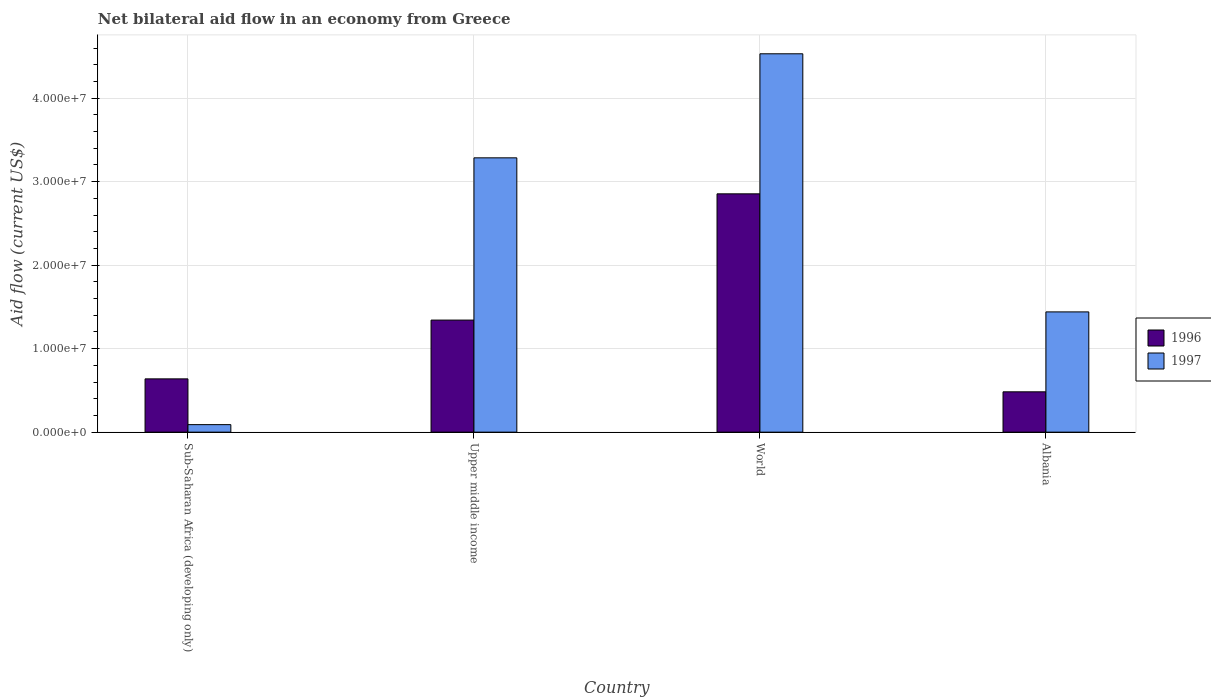How many groups of bars are there?
Your response must be concise. 4. Are the number of bars per tick equal to the number of legend labels?
Ensure brevity in your answer.  Yes. Are the number of bars on each tick of the X-axis equal?
Ensure brevity in your answer.  Yes. What is the label of the 2nd group of bars from the left?
Keep it short and to the point. Upper middle income. What is the net bilateral aid flow in 1997 in Albania?
Offer a very short reply. 1.44e+07. Across all countries, what is the maximum net bilateral aid flow in 1996?
Provide a short and direct response. 2.85e+07. In which country was the net bilateral aid flow in 1997 minimum?
Your answer should be very brief. Sub-Saharan Africa (developing only). What is the total net bilateral aid flow in 1996 in the graph?
Offer a terse response. 5.32e+07. What is the difference between the net bilateral aid flow in 1997 in Albania and that in World?
Provide a short and direct response. -3.09e+07. What is the difference between the net bilateral aid flow in 1997 in Albania and the net bilateral aid flow in 1996 in World?
Provide a short and direct response. -1.41e+07. What is the average net bilateral aid flow in 1997 per country?
Make the answer very short. 2.34e+07. What is the difference between the net bilateral aid flow of/in 1997 and net bilateral aid flow of/in 1996 in Upper middle income?
Offer a very short reply. 1.94e+07. In how many countries, is the net bilateral aid flow in 1997 greater than 36000000 US$?
Offer a terse response. 1. What is the ratio of the net bilateral aid flow in 1996 in Sub-Saharan Africa (developing only) to that in Upper middle income?
Your answer should be very brief. 0.48. What is the difference between the highest and the second highest net bilateral aid flow in 1997?
Provide a short and direct response. 3.09e+07. What is the difference between the highest and the lowest net bilateral aid flow in 1997?
Keep it short and to the point. 4.44e+07. Is the sum of the net bilateral aid flow in 1997 in Upper middle income and World greater than the maximum net bilateral aid flow in 1996 across all countries?
Keep it short and to the point. Yes. How many countries are there in the graph?
Your answer should be compact. 4. What is the difference between two consecutive major ticks on the Y-axis?
Provide a short and direct response. 1.00e+07. Does the graph contain any zero values?
Provide a succinct answer. No. Does the graph contain grids?
Ensure brevity in your answer.  Yes. Where does the legend appear in the graph?
Your response must be concise. Center right. How are the legend labels stacked?
Offer a very short reply. Vertical. What is the title of the graph?
Your answer should be compact. Net bilateral aid flow in an economy from Greece. What is the label or title of the Y-axis?
Provide a short and direct response. Aid flow (current US$). What is the Aid flow (current US$) of 1996 in Sub-Saharan Africa (developing only)?
Offer a terse response. 6.38e+06. What is the Aid flow (current US$) of 1996 in Upper middle income?
Provide a succinct answer. 1.34e+07. What is the Aid flow (current US$) in 1997 in Upper middle income?
Your answer should be very brief. 3.28e+07. What is the Aid flow (current US$) of 1996 in World?
Provide a succinct answer. 2.85e+07. What is the Aid flow (current US$) of 1997 in World?
Your answer should be very brief. 4.53e+07. What is the Aid flow (current US$) of 1996 in Albania?
Give a very brief answer. 4.83e+06. What is the Aid flow (current US$) of 1997 in Albania?
Keep it short and to the point. 1.44e+07. Across all countries, what is the maximum Aid flow (current US$) in 1996?
Provide a short and direct response. 2.85e+07. Across all countries, what is the maximum Aid flow (current US$) in 1997?
Provide a succinct answer. 4.53e+07. Across all countries, what is the minimum Aid flow (current US$) of 1996?
Provide a short and direct response. 4.83e+06. Across all countries, what is the minimum Aid flow (current US$) of 1997?
Make the answer very short. 9.00e+05. What is the total Aid flow (current US$) in 1996 in the graph?
Your response must be concise. 5.32e+07. What is the total Aid flow (current US$) of 1997 in the graph?
Give a very brief answer. 9.35e+07. What is the difference between the Aid flow (current US$) of 1996 in Sub-Saharan Africa (developing only) and that in Upper middle income?
Offer a terse response. -7.04e+06. What is the difference between the Aid flow (current US$) of 1997 in Sub-Saharan Africa (developing only) and that in Upper middle income?
Make the answer very short. -3.20e+07. What is the difference between the Aid flow (current US$) in 1996 in Sub-Saharan Africa (developing only) and that in World?
Provide a short and direct response. -2.22e+07. What is the difference between the Aid flow (current US$) of 1997 in Sub-Saharan Africa (developing only) and that in World?
Provide a succinct answer. -4.44e+07. What is the difference between the Aid flow (current US$) of 1996 in Sub-Saharan Africa (developing only) and that in Albania?
Your answer should be compact. 1.55e+06. What is the difference between the Aid flow (current US$) in 1997 in Sub-Saharan Africa (developing only) and that in Albania?
Provide a short and direct response. -1.35e+07. What is the difference between the Aid flow (current US$) of 1996 in Upper middle income and that in World?
Ensure brevity in your answer.  -1.51e+07. What is the difference between the Aid flow (current US$) of 1997 in Upper middle income and that in World?
Make the answer very short. -1.25e+07. What is the difference between the Aid flow (current US$) of 1996 in Upper middle income and that in Albania?
Your answer should be very brief. 8.59e+06. What is the difference between the Aid flow (current US$) of 1997 in Upper middle income and that in Albania?
Your answer should be very brief. 1.84e+07. What is the difference between the Aid flow (current US$) of 1996 in World and that in Albania?
Offer a terse response. 2.37e+07. What is the difference between the Aid flow (current US$) of 1997 in World and that in Albania?
Your answer should be compact. 3.09e+07. What is the difference between the Aid flow (current US$) of 1996 in Sub-Saharan Africa (developing only) and the Aid flow (current US$) of 1997 in Upper middle income?
Offer a terse response. -2.65e+07. What is the difference between the Aid flow (current US$) in 1996 in Sub-Saharan Africa (developing only) and the Aid flow (current US$) in 1997 in World?
Your answer should be compact. -3.89e+07. What is the difference between the Aid flow (current US$) of 1996 in Sub-Saharan Africa (developing only) and the Aid flow (current US$) of 1997 in Albania?
Provide a succinct answer. -8.02e+06. What is the difference between the Aid flow (current US$) of 1996 in Upper middle income and the Aid flow (current US$) of 1997 in World?
Provide a succinct answer. -3.19e+07. What is the difference between the Aid flow (current US$) of 1996 in Upper middle income and the Aid flow (current US$) of 1997 in Albania?
Keep it short and to the point. -9.80e+05. What is the difference between the Aid flow (current US$) of 1996 in World and the Aid flow (current US$) of 1997 in Albania?
Offer a terse response. 1.41e+07. What is the average Aid flow (current US$) in 1996 per country?
Your response must be concise. 1.33e+07. What is the average Aid flow (current US$) of 1997 per country?
Offer a terse response. 2.34e+07. What is the difference between the Aid flow (current US$) of 1996 and Aid flow (current US$) of 1997 in Sub-Saharan Africa (developing only)?
Make the answer very short. 5.48e+06. What is the difference between the Aid flow (current US$) in 1996 and Aid flow (current US$) in 1997 in Upper middle income?
Offer a very short reply. -1.94e+07. What is the difference between the Aid flow (current US$) of 1996 and Aid flow (current US$) of 1997 in World?
Provide a short and direct response. -1.68e+07. What is the difference between the Aid flow (current US$) of 1996 and Aid flow (current US$) of 1997 in Albania?
Your response must be concise. -9.57e+06. What is the ratio of the Aid flow (current US$) of 1996 in Sub-Saharan Africa (developing only) to that in Upper middle income?
Keep it short and to the point. 0.48. What is the ratio of the Aid flow (current US$) in 1997 in Sub-Saharan Africa (developing only) to that in Upper middle income?
Provide a succinct answer. 0.03. What is the ratio of the Aid flow (current US$) in 1996 in Sub-Saharan Africa (developing only) to that in World?
Give a very brief answer. 0.22. What is the ratio of the Aid flow (current US$) of 1997 in Sub-Saharan Africa (developing only) to that in World?
Your answer should be compact. 0.02. What is the ratio of the Aid flow (current US$) of 1996 in Sub-Saharan Africa (developing only) to that in Albania?
Your answer should be very brief. 1.32. What is the ratio of the Aid flow (current US$) in 1997 in Sub-Saharan Africa (developing only) to that in Albania?
Keep it short and to the point. 0.06. What is the ratio of the Aid flow (current US$) of 1996 in Upper middle income to that in World?
Give a very brief answer. 0.47. What is the ratio of the Aid flow (current US$) of 1997 in Upper middle income to that in World?
Your answer should be very brief. 0.72. What is the ratio of the Aid flow (current US$) in 1996 in Upper middle income to that in Albania?
Your answer should be very brief. 2.78. What is the ratio of the Aid flow (current US$) in 1997 in Upper middle income to that in Albania?
Keep it short and to the point. 2.28. What is the ratio of the Aid flow (current US$) of 1996 in World to that in Albania?
Provide a succinct answer. 5.91. What is the ratio of the Aid flow (current US$) of 1997 in World to that in Albania?
Offer a very short reply. 3.15. What is the difference between the highest and the second highest Aid flow (current US$) in 1996?
Provide a succinct answer. 1.51e+07. What is the difference between the highest and the second highest Aid flow (current US$) of 1997?
Your response must be concise. 1.25e+07. What is the difference between the highest and the lowest Aid flow (current US$) in 1996?
Your answer should be compact. 2.37e+07. What is the difference between the highest and the lowest Aid flow (current US$) of 1997?
Provide a succinct answer. 4.44e+07. 